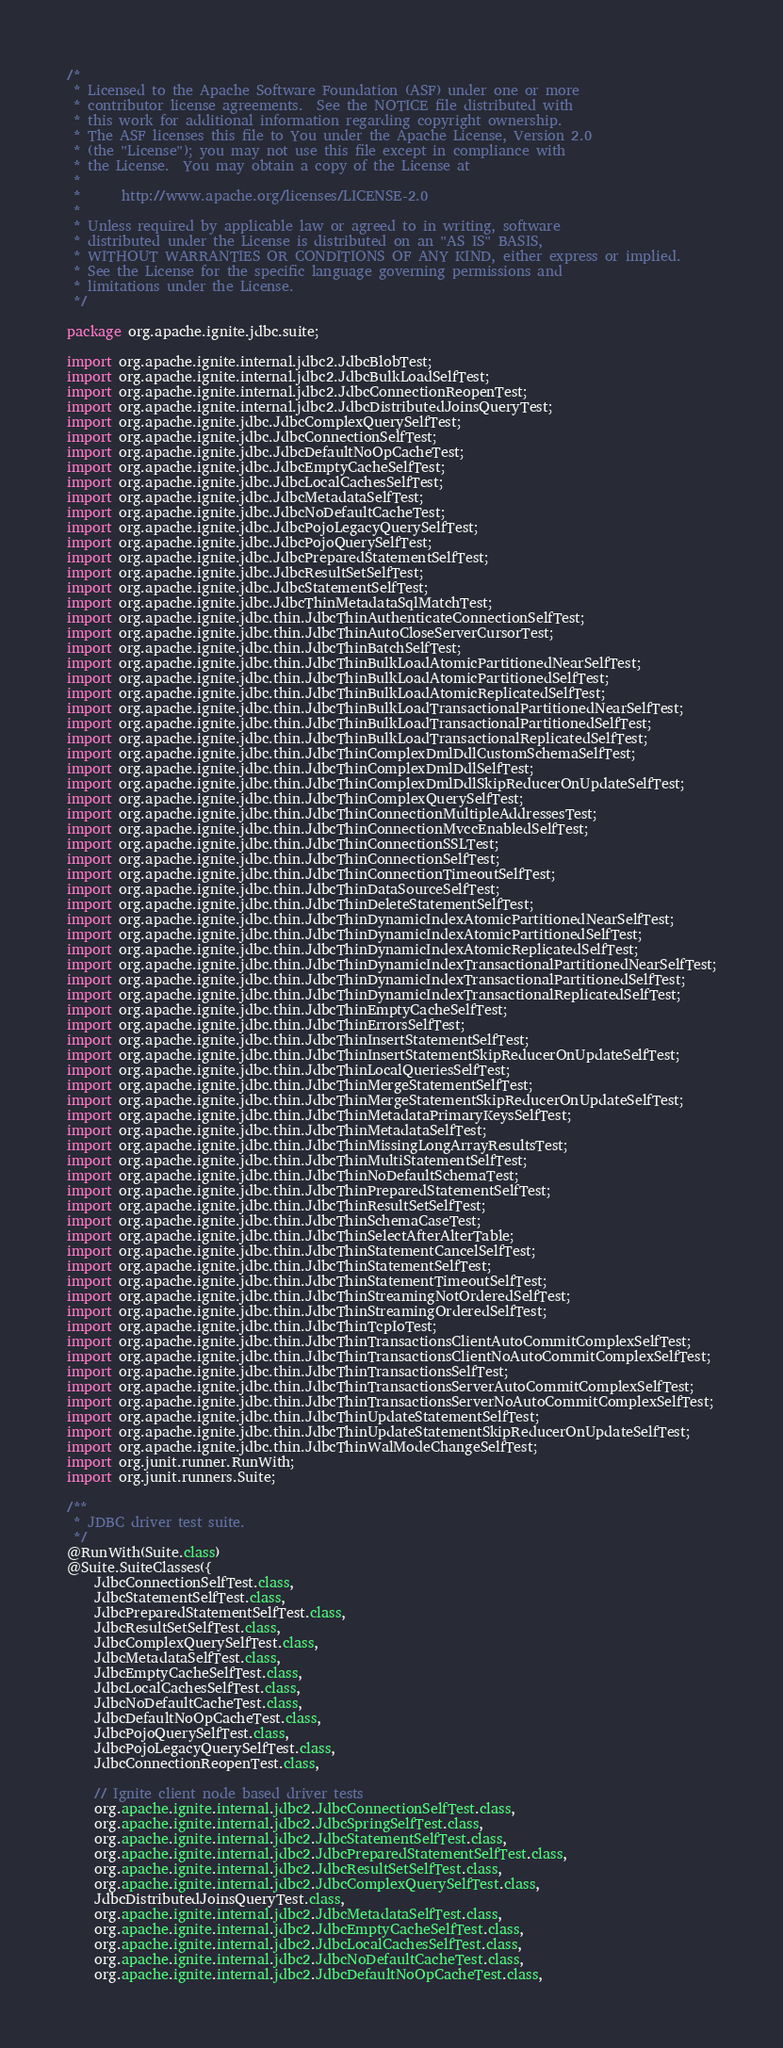<code> <loc_0><loc_0><loc_500><loc_500><_Java_>/*
 * Licensed to the Apache Software Foundation (ASF) under one or more
 * contributor license agreements.  See the NOTICE file distributed with
 * this work for additional information regarding copyright ownership.
 * The ASF licenses this file to You under the Apache License, Version 2.0
 * (the "License"); you may not use this file except in compliance with
 * the License.  You may obtain a copy of the License at
 *
 *      http://www.apache.org/licenses/LICENSE-2.0
 *
 * Unless required by applicable law or agreed to in writing, software
 * distributed under the License is distributed on an "AS IS" BASIS,
 * WITHOUT WARRANTIES OR CONDITIONS OF ANY KIND, either express or implied.
 * See the License for the specific language governing permissions and
 * limitations under the License.
 */

package org.apache.ignite.jdbc.suite;

import org.apache.ignite.internal.jdbc2.JdbcBlobTest;
import org.apache.ignite.internal.jdbc2.JdbcBulkLoadSelfTest;
import org.apache.ignite.internal.jdbc2.JdbcConnectionReopenTest;
import org.apache.ignite.internal.jdbc2.JdbcDistributedJoinsQueryTest;
import org.apache.ignite.jdbc.JdbcComplexQuerySelfTest;
import org.apache.ignite.jdbc.JdbcConnectionSelfTest;
import org.apache.ignite.jdbc.JdbcDefaultNoOpCacheTest;
import org.apache.ignite.jdbc.JdbcEmptyCacheSelfTest;
import org.apache.ignite.jdbc.JdbcLocalCachesSelfTest;
import org.apache.ignite.jdbc.JdbcMetadataSelfTest;
import org.apache.ignite.jdbc.JdbcNoDefaultCacheTest;
import org.apache.ignite.jdbc.JdbcPojoLegacyQuerySelfTest;
import org.apache.ignite.jdbc.JdbcPojoQuerySelfTest;
import org.apache.ignite.jdbc.JdbcPreparedStatementSelfTest;
import org.apache.ignite.jdbc.JdbcResultSetSelfTest;
import org.apache.ignite.jdbc.JdbcStatementSelfTest;
import org.apache.ignite.jdbc.JdbcThinMetadataSqlMatchTest;
import org.apache.ignite.jdbc.thin.JdbcThinAuthenticateConnectionSelfTest;
import org.apache.ignite.jdbc.thin.JdbcThinAutoCloseServerCursorTest;
import org.apache.ignite.jdbc.thin.JdbcThinBatchSelfTest;
import org.apache.ignite.jdbc.thin.JdbcThinBulkLoadAtomicPartitionedNearSelfTest;
import org.apache.ignite.jdbc.thin.JdbcThinBulkLoadAtomicPartitionedSelfTest;
import org.apache.ignite.jdbc.thin.JdbcThinBulkLoadAtomicReplicatedSelfTest;
import org.apache.ignite.jdbc.thin.JdbcThinBulkLoadTransactionalPartitionedNearSelfTest;
import org.apache.ignite.jdbc.thin.JdbcThinBulkLoadTransactionalPartitionedSelfTest;
import org.apache.ignite.jdbc.thin.JdbcThinBulkLoadTransactionalReplicatedSelfTest;
import org.apache.ignite.jdbc.thin.JdbcThinComplexDmlDdlCustomSchemaSelfTest;
import org.apache.ignite.jdbc.thin.JdbcThinComplexDmlDdlSelfTest;
import org.apache.ignite.jdbc.thin.JdbcThinComplexDmlDdlSkipReducerOnUpdateSelfTest;
import org.apache.ignite.jdbc.thin.JdbcThinComplexQuerySelfTest;
import org.apache.ignite.jdbc.thin.JdbcThinConnectionMultipleAddressesTest;
import org.apache.ignite.jdbc.thin.JdbcThinConnectionMvccEnabledSelfTest;
import org.apache.ignite.jdbc.thin.JdbcThinConnectionSSLTest;
import org.apache.ignite.jdbc.thin.JdbcThinConnectionSelfTest;
import org.apache.ignite.jdbc.thin.JdbcThinConnectionTimeoutSelfTest;
import org.apache.ignite.jdbc.thin.JdbcThinDataSourceSelfTest;
import org.apache.ignite.jdbc.thin.JdbcThinDeleteStatementSelfTest;
import org.apache.ignite.jdbc.thin.JdbcThinDynamicIndexAtomicPartitionedNearSelfTest;
import org.apache.ignite.jdbc.thin.JdbcThinDynamicIndexAtomicPartitionedSelfTest;
import org.apache.ignite.jdbc.thin.JdbcThinDynamicIndexAtomicReplicatedSelfTest;
import org.apache.ignite.jdbc.thin.JdbcThinDynamicIndexTransactionalPartitionedNearSelfTest;
import org.apache.ignite.jdbc.thin.JdbcThinDynamicIndexTransactionalPartitionedSelfTest;
import org.apache.ignite.jdbc.thin.JdbcThinDynamicIndexTransactionalReplicatedSelfTest;
import org.apache.ignite.jdbc.thin.JdbcThinEmptyCacheSelfTest;
import org.apache.ignite.jdbc.thin.JdbcThinErrorsSelfTest;
import org.apache.ignite.jdbc.thin.JdbcThinInsertStatementSelfTest;
import org.apache.ignite.jdbc.thin.JdbcThinInsertStatementSkipReducerOnUpdateSelfTest;
import org.apache.ignite.jdbc.thin.JdbcThinLocalQueriesSelfTest;
import org.apache.ignite.jdbc.thin.JdbcThinMergeStatementSelfTest;
import org.apache.ignite.jdbc.thin.JdbcThinMergeStatementSkipReducerOnUpdateSelfTest;
import org.apache.ignite.jdbc.thin.JdbcThinMetadataPrimaryKeysSelfTest;
import org.apache.ignite.jdbc.thin.JdbcThinMetadataSelfTest;
import org.apache.ignite.jdbc.thin.JdbcThinMissingLongArrayResultsTest;
import org.apache.ignite.jdbc.thin.JdbcThinMultiStatementSelfTest;
import org.apache.ignite.jdbc.thin.JdbcThinNoDefaultSchemaTest;
import org.apache.ignite.jdbc.thin.JdbcThinPreparedStatementSelfTest;
import org.apache.ignite.jdbc.thin.JdbcThinResultSetSelfTest;
import org.apache.ignite.jdbc.thin.JdbcThinSchemaCaseTest;
import org.apache.ignite.jdbc.thin.JdbcThinSelectAfterAlterTable;
import org.apache.ignite.jdbc.thin.JdbcThinStatementCancelSelfTest;
import org.apache.ignite.jdbc.thin.JdbcThinStatementSelfTest;
import org.apache.ignite.jdbc.thin.JdbcThinStatementTimeoutSelfTest;
import org.apache.ignite.jdbc.thin.JdbcThinStreamingNotOrderedSelfTest;
import org.apache.ignite.jdbc.thin.JdbcThinStreamingOrderedSelfTest;
import org.apache.ignite.jdbc.thin.JdbcThinTcpIoTest;
import org.apache.ignite.jdbc.thin.JdbcThinTransactionsClientAutoCommitComplexSelfTest;
import org.apache.ignite.jdbc.thin.JdbcThinTransactionsClientNoAutoCommitComplexSelfTest;
import org.apache.ignite.jdbc.thin.JdbcThinTransactionsSelfTest;
import org.apache.ignite.jdbc.thin.JdbcThinTransactionsServerAutoCommitComplexSelfTest;
import org.apache.ignite.jdbc.thin.JdbcThinTransactionsServerNoAutoCommitComplexSelfTest;
import org.apache.ignite.jdbc.thin.JdbcThinUpdateStatementSelfTest;
import org.apache.ignite.jdbc.thin.JdbcThinUpdateStatementSkipReducerOnUpdateSelfTest;
import org.apache.ignite.jdbc.thin.JdbcThinWalModeChangeSelfTest;
import org.junit.runner.RunWith;
import org.junit.runners.Suite;

/**
 * JDBC driver test suite.
 */
@RunWith(Suite.class)
@Suite.SuiteClasses({
    JdbcConnectionSelfTest.class,
    JdbcStatementSelfTest.class,
    JdbcPreparedStatementSelfTest.class,
    JdbcResultSetSelfTest.class,
    JdbcComplexQuerySelfTest.class,
    JdbcMetadataSelfTest.class,
    JdbcEmptyCacheSelfTest.class,
    JdbcLocalCachesSelfTest.class,
    JdbcNoDefaultCacheTest.class,
    JdbcDefaultNoOpCacheTest.class,
    JdbcPojoQuerySelfTest.class,
    JdbcPojoLegacyQuerySelfTest.class,
    JdbcConnectionReopenTest.class,

    // Ignite client node based driver tests
    org.apache.ignite.internal.jdbc2.JdbcConnectionSelfTest.class,
    org.apache.ignite.internal.jdbc2.JdbcSpringSelfTest.class,
    org.apache.ignite.internal.jdbc2.JdbcStatementSelfTest.class,
    org.apache.ignite.internal.jdbc2.JdbcPreparedStatementSelfTest.class,
    org.apache.ignite.internal.jdbc2.JdbcResultSetSelfTest.class,
    org.apache.ignite.internal.jdbc2.JdbcComplexQuerySelfTest.class,
    JdbcDistributedJoinsQueryTest.class,
    org.apache.ignite.internal.jdbc2.JdbcMetadataSelfTest.class,
    org.apache.ignite.internal.jdbc2.JdbcEmptyCacheSelfTest.class,
    org.apache.ignite.internal.jdbc2.JdbcLocalCachesSelfTest.class,
    org.apache.ignite.internal.jdbc2.JdbcNoDefaultCacheTest.class,
    org.apache.ignite.internal.jdbc2.JdbcDefaultNoOpCacheTest.class,</code> 